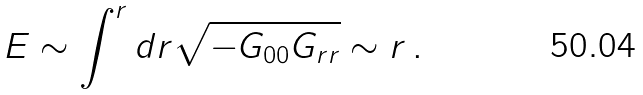<formula> <loc_0><loc_0><loc_500><loc_500>E \sim \int ^ { r } d r \sqrt { - G _ { 0 0 } G _ { r r } } \sim r \, .</formula> 